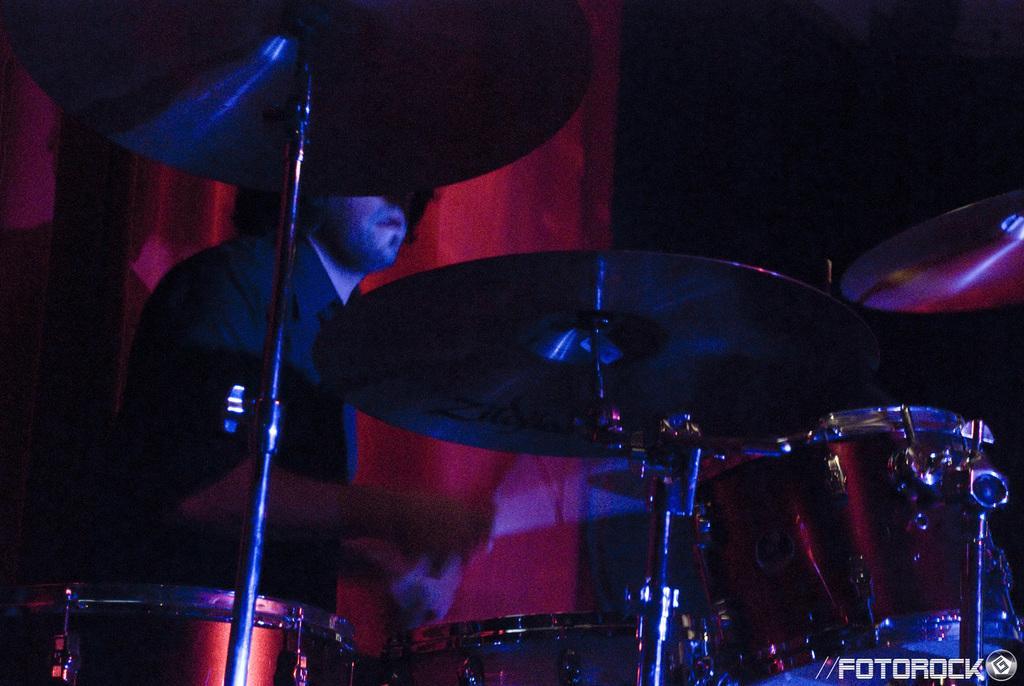Please provide a concise description of this image. In the picture we can see a man playing an orchestra and he is in the black shirt and behind him we can see a curtain which is red in color. 